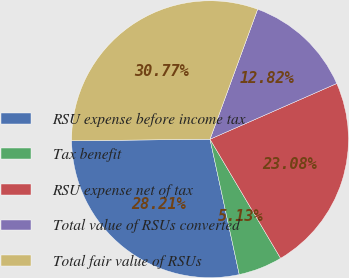Convert chart to OTSL. <chart><loc_0><loc_0><loc_500><loc_500><pie_chart><fcel>RSU expense before income tax<fcel>Tax benefit<fcel>RSU expense net of tax<fcel>Total value of RSUs converted<fcel>Total fair value of RSUs<nl><fcel>28.21%<fcel>5.13%<fcel>23.08%<fcel>12.82%<fcel>30.77%<nl></chart> 